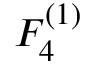Convert formula to latex. <formula><loc_0><loc_0><loc_500><loc_500>{ F } _ { 4 } ^ { ( 1 ) }</formula> 